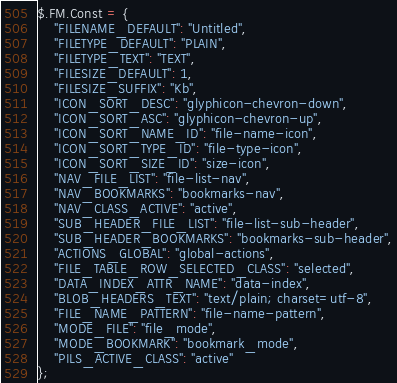Convert code to text. <code><loc_0><loc_0><loc_500><loc_500><_JavaScript_>$.FM.Const = {
	"FILENAME_DEFAULT": "Untitled",
	"FILETYPE_DEFAULT": "PLAIN",
	"FILETYPE_TEXT": "TEXT",
	"FILESIZE_DEFAULT": 1,
	"FILESIZE_SUFFIX": "Kb",
	"ICON_SORT_DESC": "glyphicon-chevron-down",
	"ICON_SORT_ASC": "glyphicon-chevron-up",
	"ICON_SORT_NAME_ID": "file-name-icon",
	"ICON_SORT_TYPE_ID": "file-type-icon",
	"ICON_SORT_SIZE_ID": "size-icon",
	"NAV_FILE_LIST": "file-list-nav",
	"NAV_BOOKMARKS": "bookmarks-nav",
	"NAV_CLASS_ACTIVE": "active",
	"SUB_HEADER_FILE_LIST": "file-list-sub-header",
	"SUB_HEADER_BOOKMARKS": "bookmarks-sub-header",
	"ACTIONS_GLOBAL": "global-actions",
	"FILE_TABLE_ROW_SELECTED_CLASS": "selected",
	"DATA_INDEX_ATTR_NAME": "data-index",
	"BLOB_HEADERS_TEXT": "text/plain; charset=utf-8",
	"FILE_NAME_PATTERN": "file-name-pattern",
	"MODE_FILE": "file_mode",
	"MODE_BOOKMARK": "bookmark_mode",
	"PILS_ACTIVE_CLASS": "active"
};</code> 